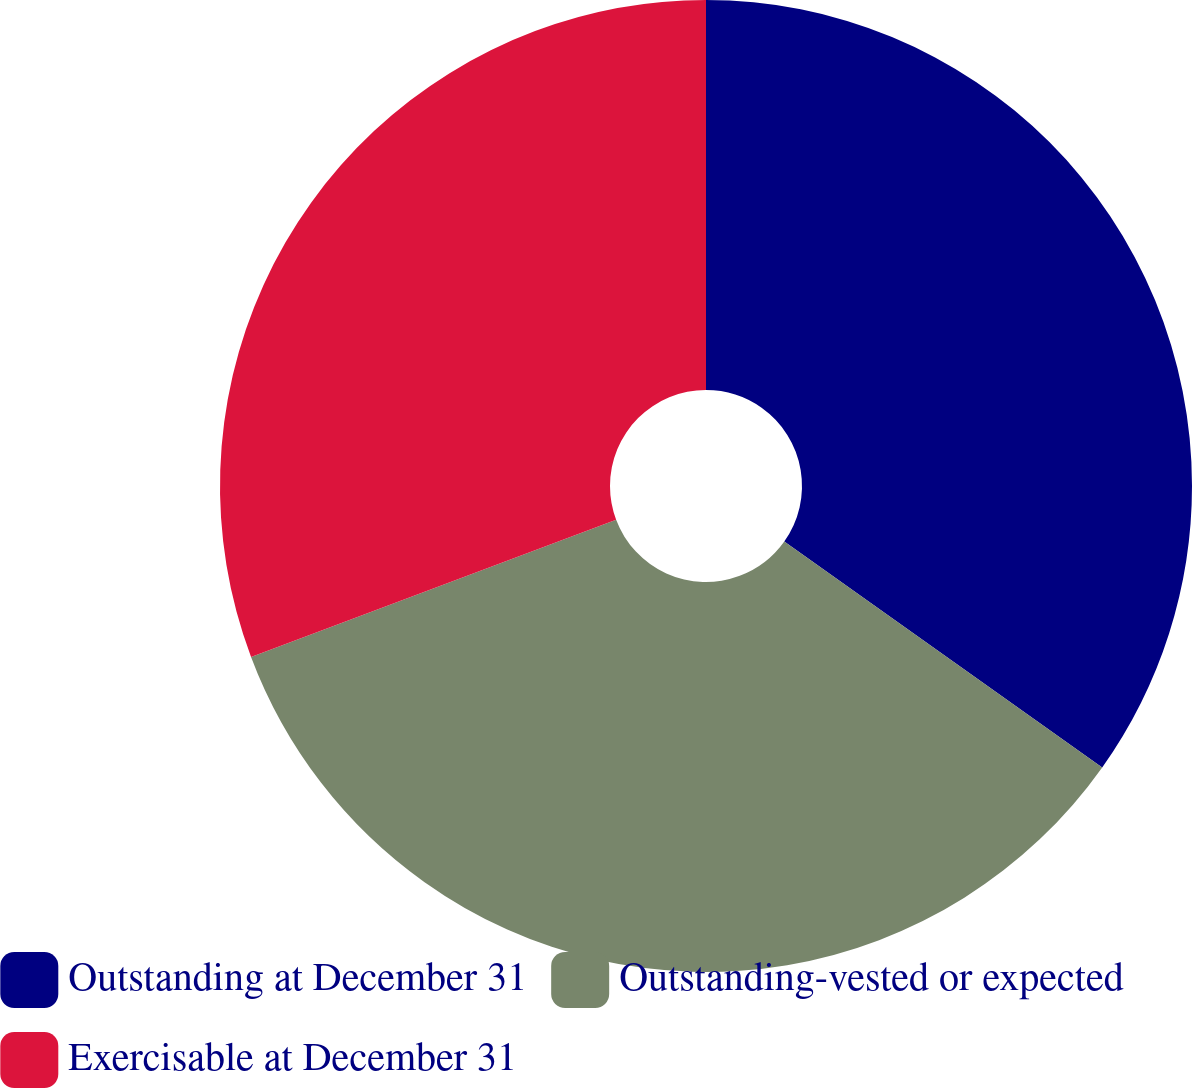Convert chart to OTSL. <chart><loc_0><loc_0><loc_500><loc_500><pie_chart><fcel>Outstanding at December 31<fcel>Outstanding-vested or expected<fcel>Exercisable at December 31<nl><fcel>34.83%<fcel>34.45%<fcel>30.72%<nl></chart> 